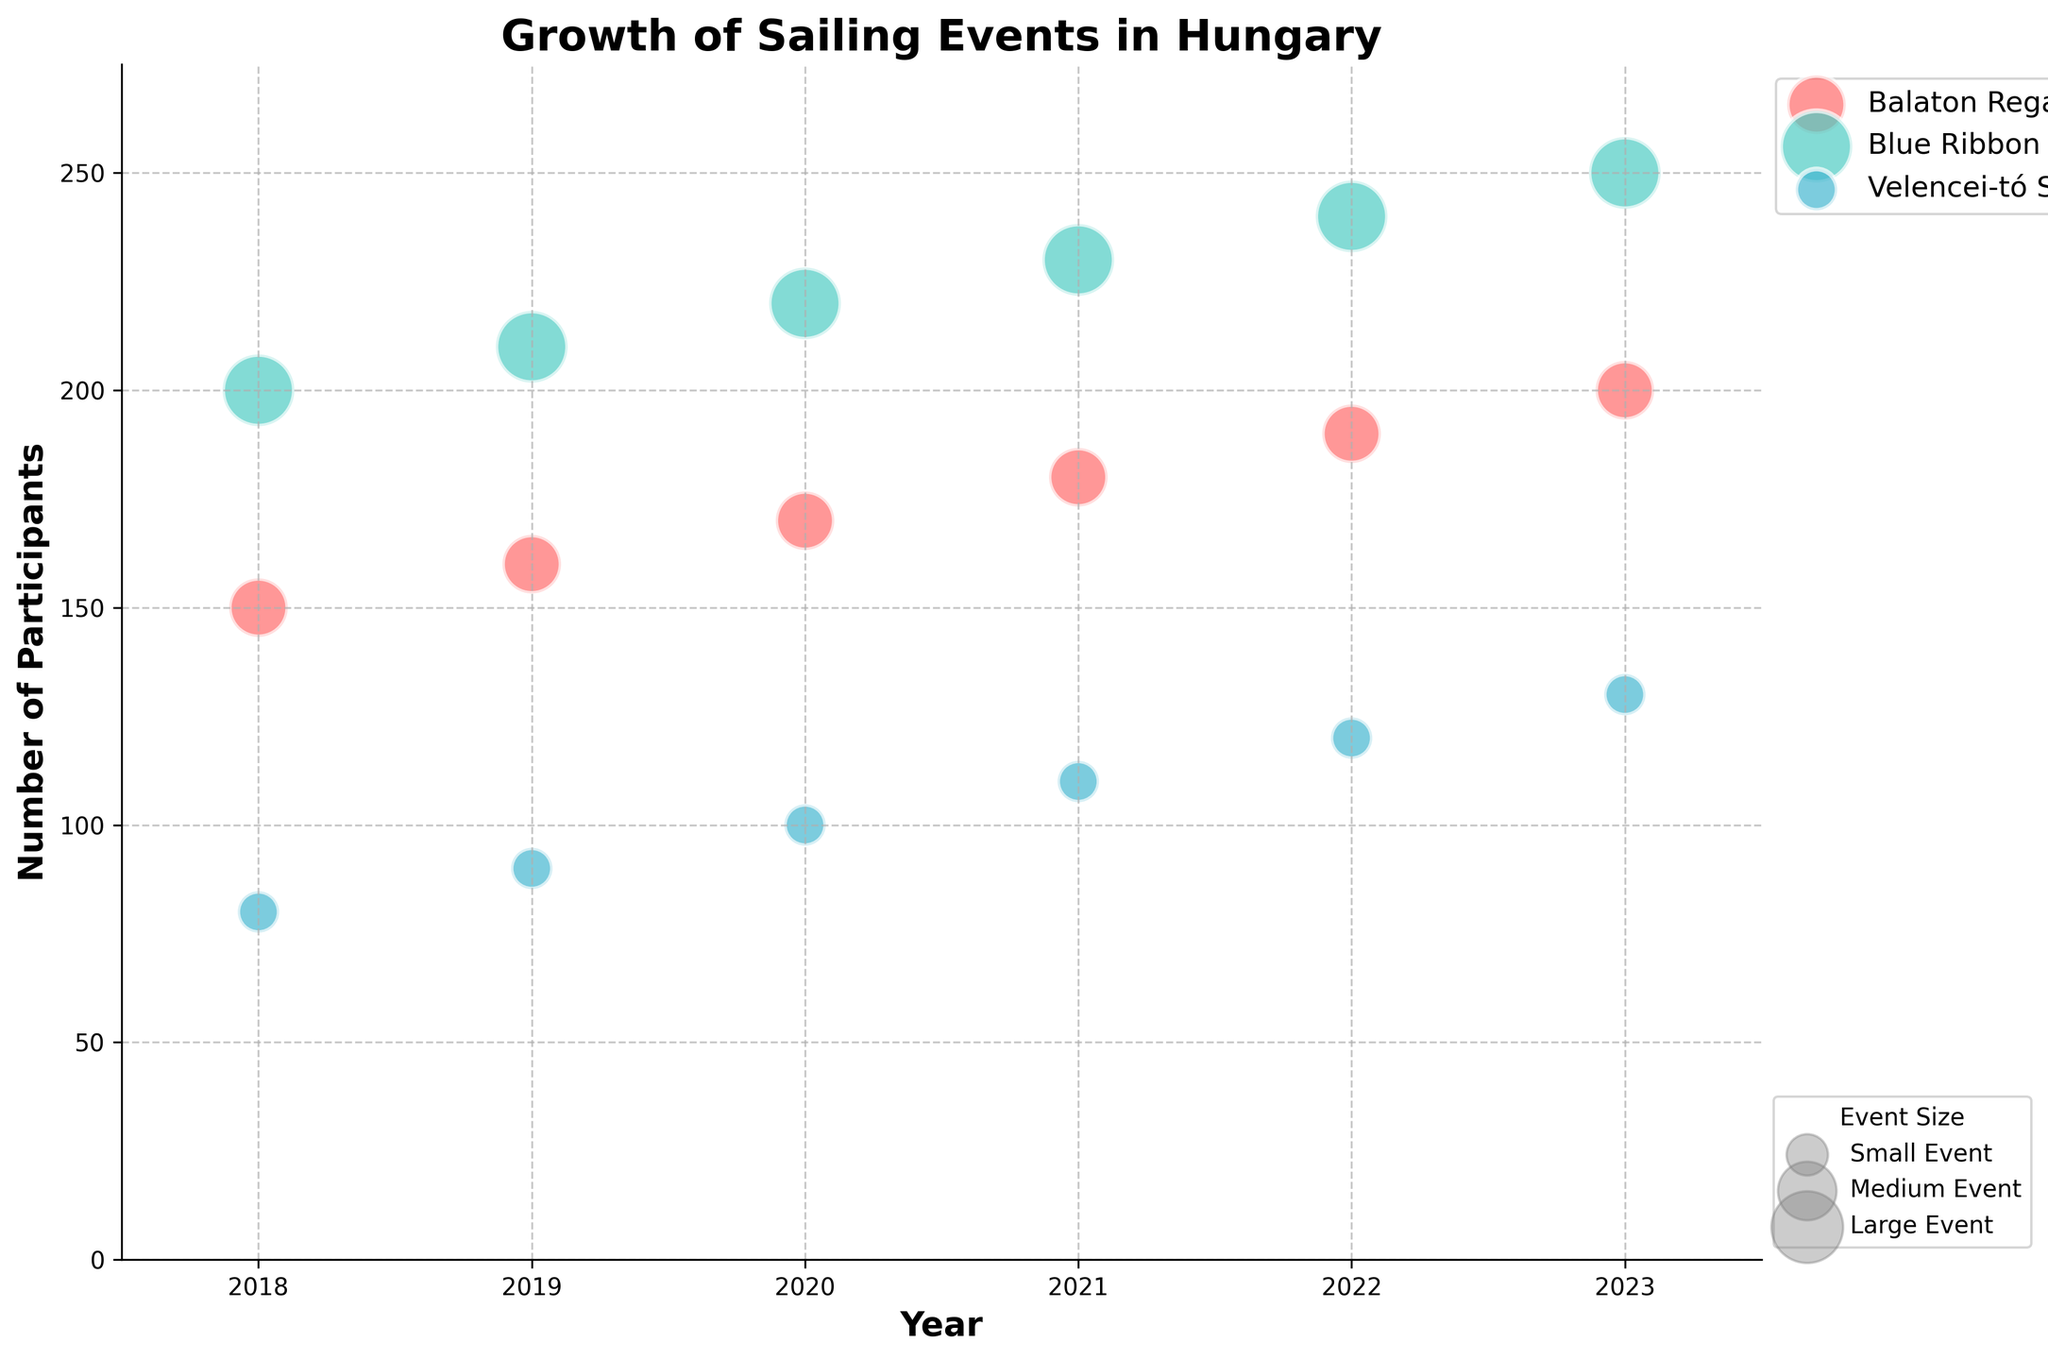How many sailing events were shown for the year 2019? There are three event names (Balaton Regatta, Blue Ribbon Round the Lake, Velencei-tó Sailing Marathon) plotted for the year 2019. Count them.
Answer: 3 What is the general trend in the number of participants for the "Blue Ribbon Round the Lake" event from 2018 to 2023? The number of participants for the "Blue Ribbon Round the Lake" event increases each year from 200 in 2018 to 250 in 2023.
Answer: Increasing trend Which event had the smallest number of participants in 2022? In 2022, the Velencei-tó Sailing Marathon had the smallest number of participants with 120. The other events had 190 and 240 participants respectively.
Answer: Velencei-tó Sailing Marathon What event size corresponds to the largest bubbles in the chart? The largest bubbles in the chart represent the "Large" event size. This is indicated by the legend.
Answer: Large In which year did the Balaton Regatta first reach 200 participants? The Balaton Regatta first reached 200 participants in the year 2023.
Answer: 2023 By how many participants did the Velencei-tó Sailing Marathon grow from 2018 to 2023? The Velencei-tó Sailing Marathon grew from 80 participants in 2018 to 130 participants in 2023. Calculate the difference: 130 - 80 = 50.
Answer: 50 Compare the number of participants between the "Medium" and "Large" size events in 2021. Which had more participants and by how much? In 2021, the "Medium" size event (Balaton Regatta) had 180 participants while the "Large" size event (Blue Ribbon Round the Lake) had 230 participants. The difference is 230 - 180 = 50 participants, with the "Large" size event having more participants.
Answer: Large, by 50 Which event shows the most significant increase in the number of participants from 2018 to 2023? Compare the increase for each event from 2018 to 2023: Balaton Regatta (200 - 150 = 50), Blue Ribbon Round the Lake (250 - 200 = 50), Velencei-tó Sailing Marathon (130 - 80 = 50). The increases are equal at 50 participants each.
Answer: All events equal, 50 What’s the average number of participants for the "Balaton Regatta" over the years shown? Sum the number of participants for the Balaton Regatta over all years: (150 + 160 + 170 + 180 + 190 + 200) = 1050. Then divide by the number of years (6): 1050 / 6 = 175.
Answer: 175 Which year saw the highest combined total number of participants across all events? Sum the participants for each year and compare: 2018 (150+200+80=430), 2019 (160+210+90=460), 2020 (170+220+100=490), 2021 (180+230+110=520), 2022 (190+240+120=550), 2023 (200+250+130=580). The highest combined total is in 2023 with 580 participants.
Answer: 2023 